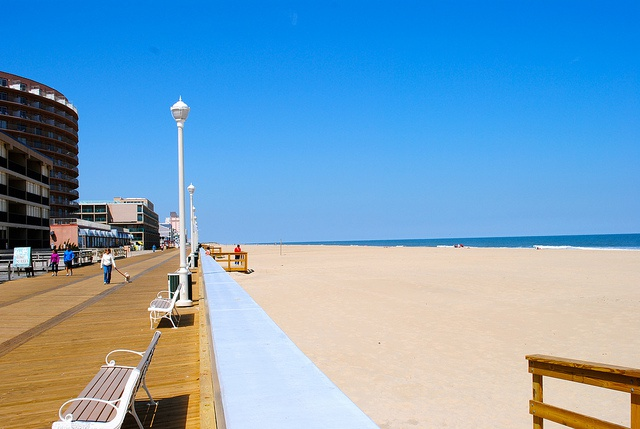Describe the objects in this image and their specific colors. I can see bench in gray, olive, tan, lightgray, and maroon tones, bench in gray, darkgray, white, and black tones, bench in gray, white, darkgray, black, and tan tones, people in gray, white, black, navy, and darkgray tones, and people in gray, black, blue, lightblue, and darkblue tones in this image. 